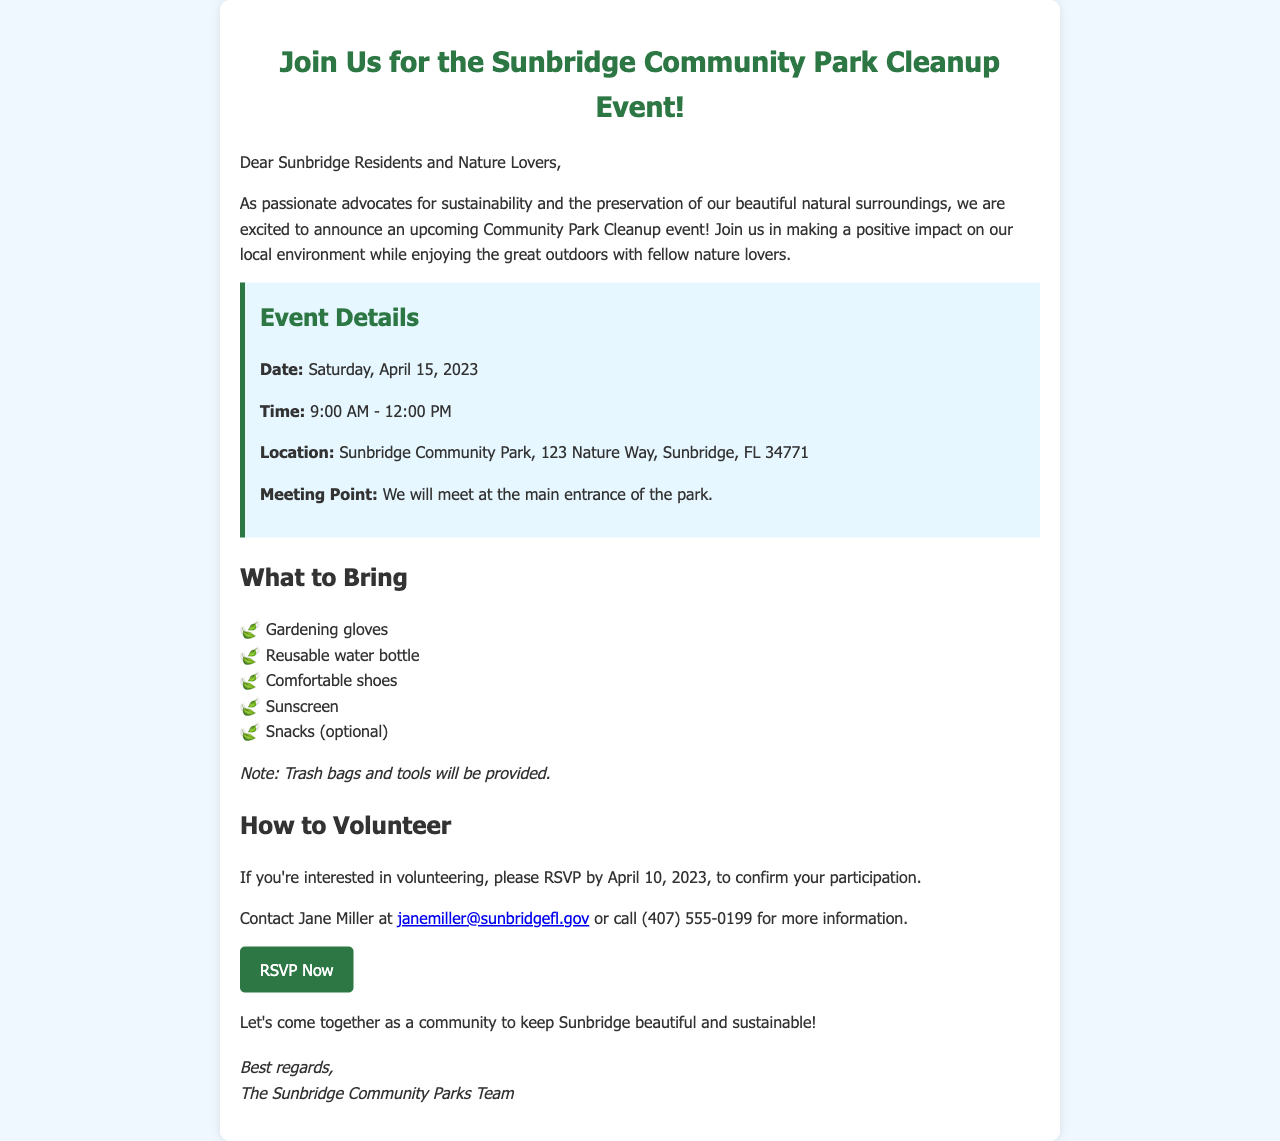What is the date of the event? The event is scheduled for Saturday, April 15, 2023, as mentioned in the event details.
Answer: Saturday, April 15, 2023 What time does the cleanup event start? The starting time for the cleanup event is specified in the event details section of the document.
Answer: 9:00 AM Where will the event take place? The document clearly states the location of the Community Park Cleanup event.
Answer: Sunbridge Community Park, 123 Nature Way, Sunbridge, FL 34771 Who should I contact for more information about volunteering? The contact person's name is given in the section about how to volunteer, along with their email and phone number.
Answer: Jane Miller What should participants bring? The document lists several items that participants are advised to bring for the cleanup event.
Answer: Gardening gloves What is provided by the organizers for the event? It is mentioned in the "What to Bring" section that certain supplies will be provided by the organizers.
Answer: Trash bags and tools When is the RSVP deadline? The RSVP deadline is highlighted in the section about how to volunteer.
Answer: April 10, 2023 What is the purpose of the event? The introduction of the document states the main goal of the community park cleanup event.
Answer: Positive impact on our local environment What kind of shoes should volunteers wear? The document advises wearing a specific type of footwear for the event.
Answer: Comfortable shoes 